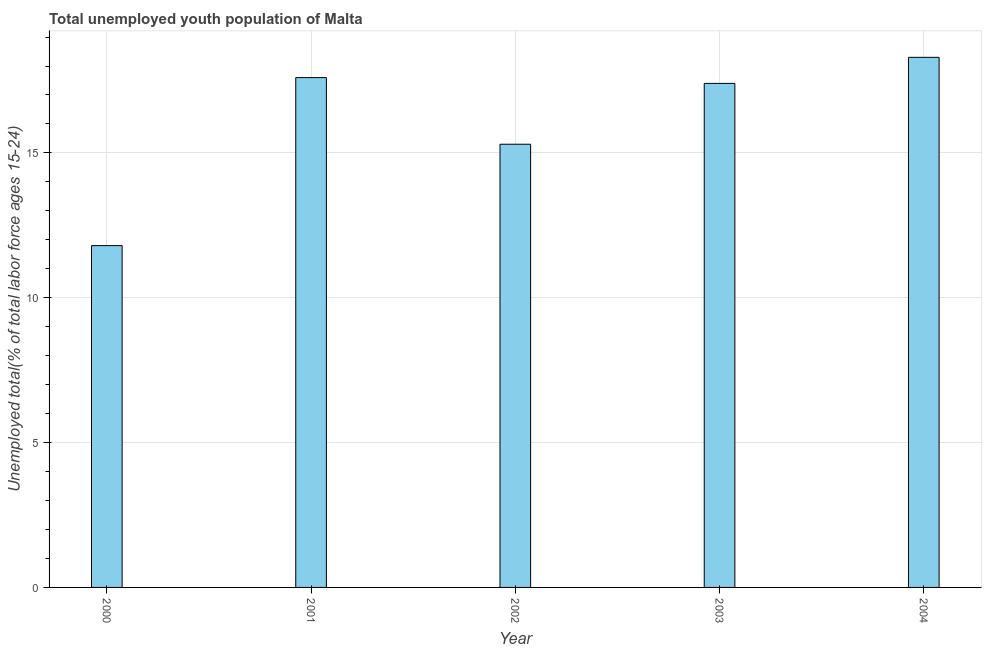Does the graph contain grids?
Make the answer very short. Yes. What is the title of the graph?
Your response must be concise. Total unemployed youth population of Malta. What is the label or title of the Y-axis?
Offer a terse response. Unemployed total(% of total labor force ages 15-24). What is the unemployed youth in 2004?
Keep it short and to the point. 18.3. Across all years, what is the maximum unemployed youth?
Make the answer very short. 18.3. Across all years, what is the minimum unemployed youth?
Your response must be concise. 11.8. In which year was the unemployed youth maximum?
Your answer should be compact. 2004. What is the sum of the unemployed youth?
Your response must be concise. 80.4. What is the average unemployed youth per year?
Keep it short and to the point. 16.08. What is the median unemployed youth?
Make the answer very short. 17.4. In how many years, is the unemployed youth greater than 3 %?
Ensure brevity in your answer.  5. What is the ratio of the unemployed youth in 2002 to that in 2003?
Provide a short and direct response. 0.88. Is the unemployed youth in 2002 less than that in 2004?
Make the answer very short. Yes. Is the difference between the unemployed youth in 2000 and 2004 greater than the difference between any two years?
Your answer should be very brief. Yes. Is the sum of the unemployed youth in 2001 and 2004 greater than the maximum unemployed youth across all years?
Make the answer very short. Yes. What is the difference between the highest and the lowest unemployed youth?
Offer a very short reply. 6.5. What is the difference between two consecutive major ticks on the Y-axis?
Offer a terse response. 5. What is the Unemployed total(% of total labor force ages 15-24) of 2000?
Your answer should be very brief. 11.8. What is the Unemployed total(% of total labor force ages 15-24) in 2001?
Your answer should be compact. 17.6. What is the Unemployed total(% of total labor force ages 15-24) of 2002?
Your answer should be very brief. 15.3. What is the Unemployed total(% of total labor force ages 15-24) in 2003?
Ensure brevity in your answer.  17.4. What is the Unemployed total(% of total labor force ages 15-24) of 2004?
Your answer should be compact. 18.3. What is the difference between the Unemployed total(% of total labor force ages 15-24) in 2000 and 2001?
Offer a terse response. -5.8. What is the difference between the Unemployed total(% of total labor force ages 15-24) in 2001 and 2003?
Make the answer very short. 0.2. What is the difference between the Unemployed total(% of total labor force ages 15-24) in 2002 and 2004?
Your response must be concise. -3. What is the difference between the Unemployed total(% of total labor force ages 15-24) in 2003 and 2004?
Offer a very short reply. -0.9. What is the ratio of the Unemployed total(% of total labor force ages 15-24) in 2000 to that in 2001?
Offer a very short reply. 0.67. What is the ratio of the Unemployed total(% of total labor force ages 15-24) in 2000 to that in 2002?
Make the answer very short. 0.77. What is the ratio of the Unemployed total(% of total labor force ages 15-24) in 2000 to that in 2003?
Provide a short and direct response. 0.68. What is the ratio of the Unemployed total(% of total labor force ages 15-24) in 2000 to that in 2004?
Provide a short and direct response. 0.65. What is the ratio of the Unemployed total(% of total labor force ages 15-24) in 2001 to that in 2002?
Offer a terse response. 1.15. What is the ratio of the Unemployed total(% of total labor force ages 15-24) in 2002 to that in 2003?
Keep it short and to the point. 0.88. What is the ratio of the Unemployed total(% of total labor force ages 15-24) in 2002 to that in 2004?
Offer a terse response. 0.84. What is the ratio of the Unemployed total(% of total labor force ages 15-24) in 2003 to that in 2004?
Your response must be concise. 0.95. 